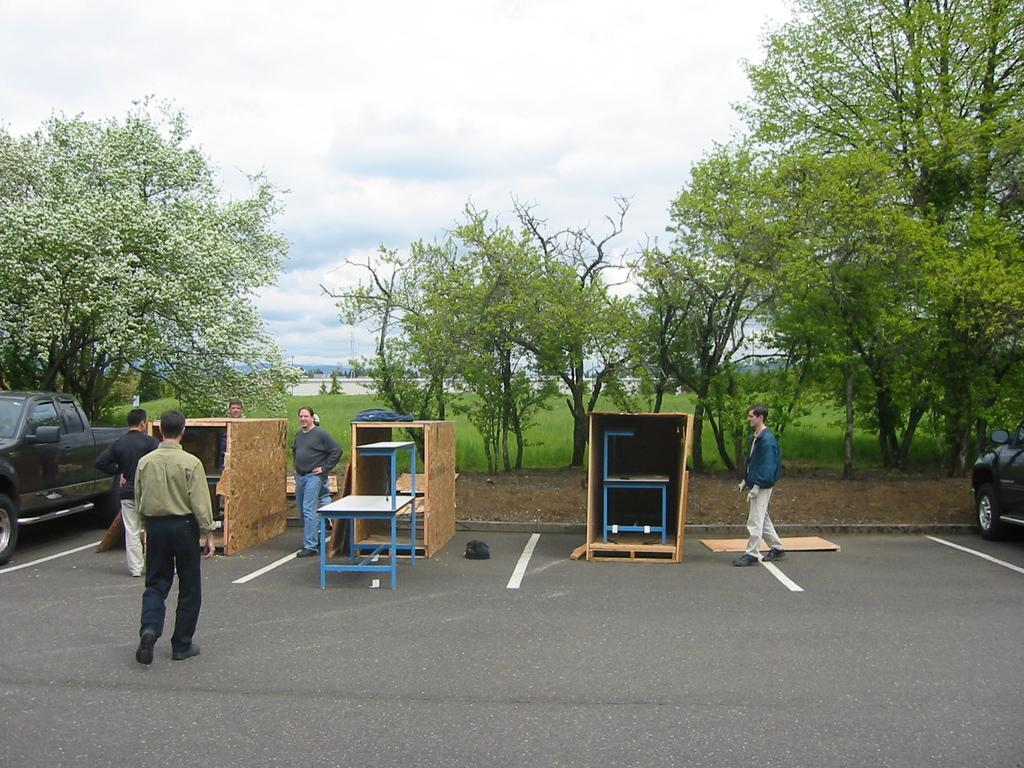How many people can be seen in the image? There are people in the image, but the exact number is not specified. What types of vehicles are present in the image? There are vehicles in the image, but the specific types are not mentioned. What is the purpose of the tables in the image? The purpose of the tables in the image is not clear, but they are likely used for placing objects or serving a function. What objects are on the road in the image? There are objects on the road in the image, but their nature is not specified. What type of vegetation is present in the image? There is grass, plants, and trees in the image. What other objects can be seen in the image? There are other objects in the image, but their nature is not specified. What is the condition of the sky in the image? The sky is cloudy in the image. What type of brick is being used to make dinner in the image? There is no mention of bricks or dinner in the image; it does not contain any information about food preparation or cooking. 